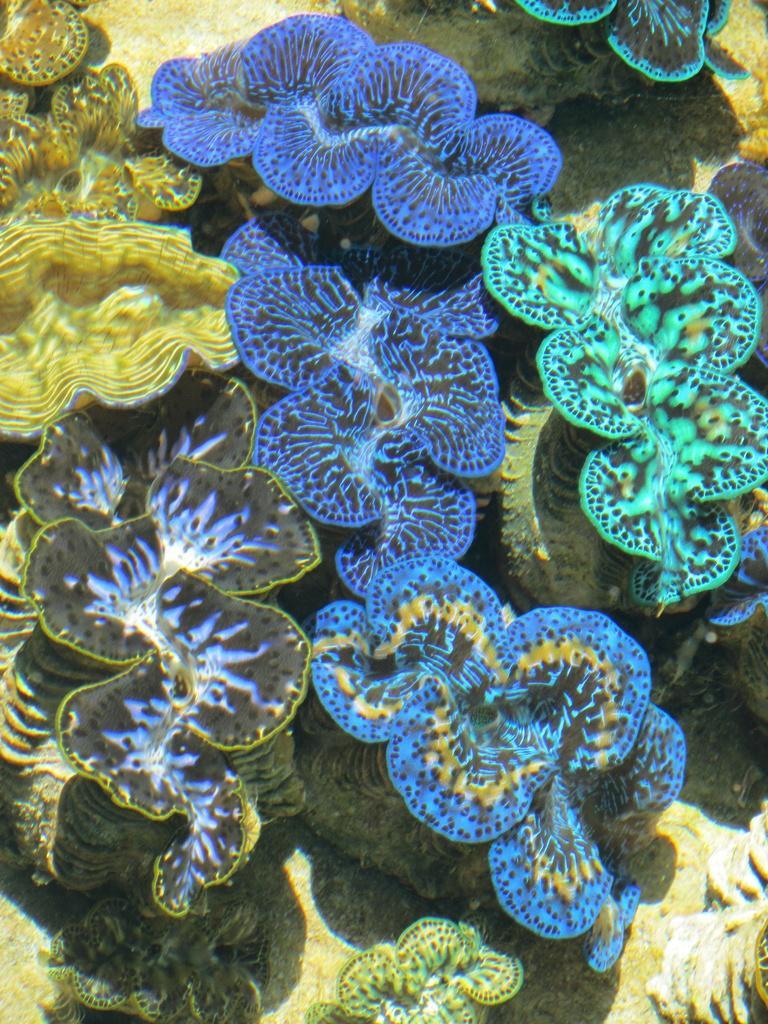In one or two sentences, can you explain what this image depicts? In the image there are different colors of water species are captured. 